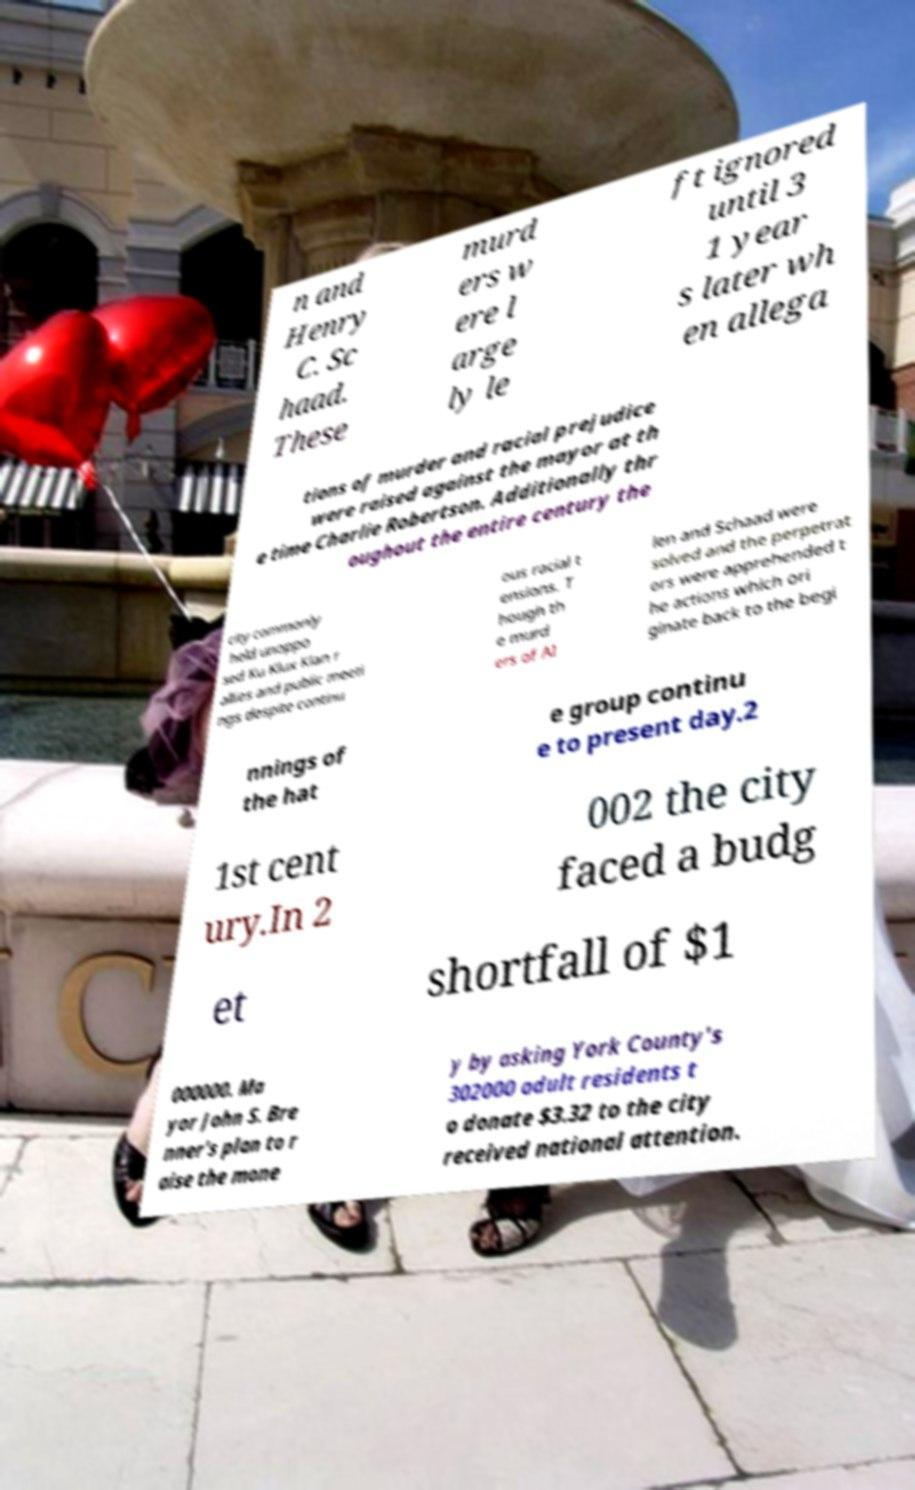Could you extract and type out the text from this image? n and Henry C. Sc haad. These murd ers w ere l arge ly le ft ignored until 3 1 year s later wh en allega tions of murder and racial prejudice were raised against the mayor at th e time Charlie Robertson. Additionally thr oughout the entire century the city commonly held unoppo sed Ku Klux Klan r allies and public meeti ngs despite continu ous racial t ensions. T hough th e murd ers of Al len and Schaad were solved and the perpetrat ors were apprehended t he actions which ori ginate back to the begi nnings of the hat e group continu e to present day.2 1st cent ury.In 2 002 the city faced a budg et shortfall of $1 000000. Ma yor John S. Bre nner's plan to r aise the mone y by asking York County's 302000 adult residents t o donate $3.32 to the city received national attention. 